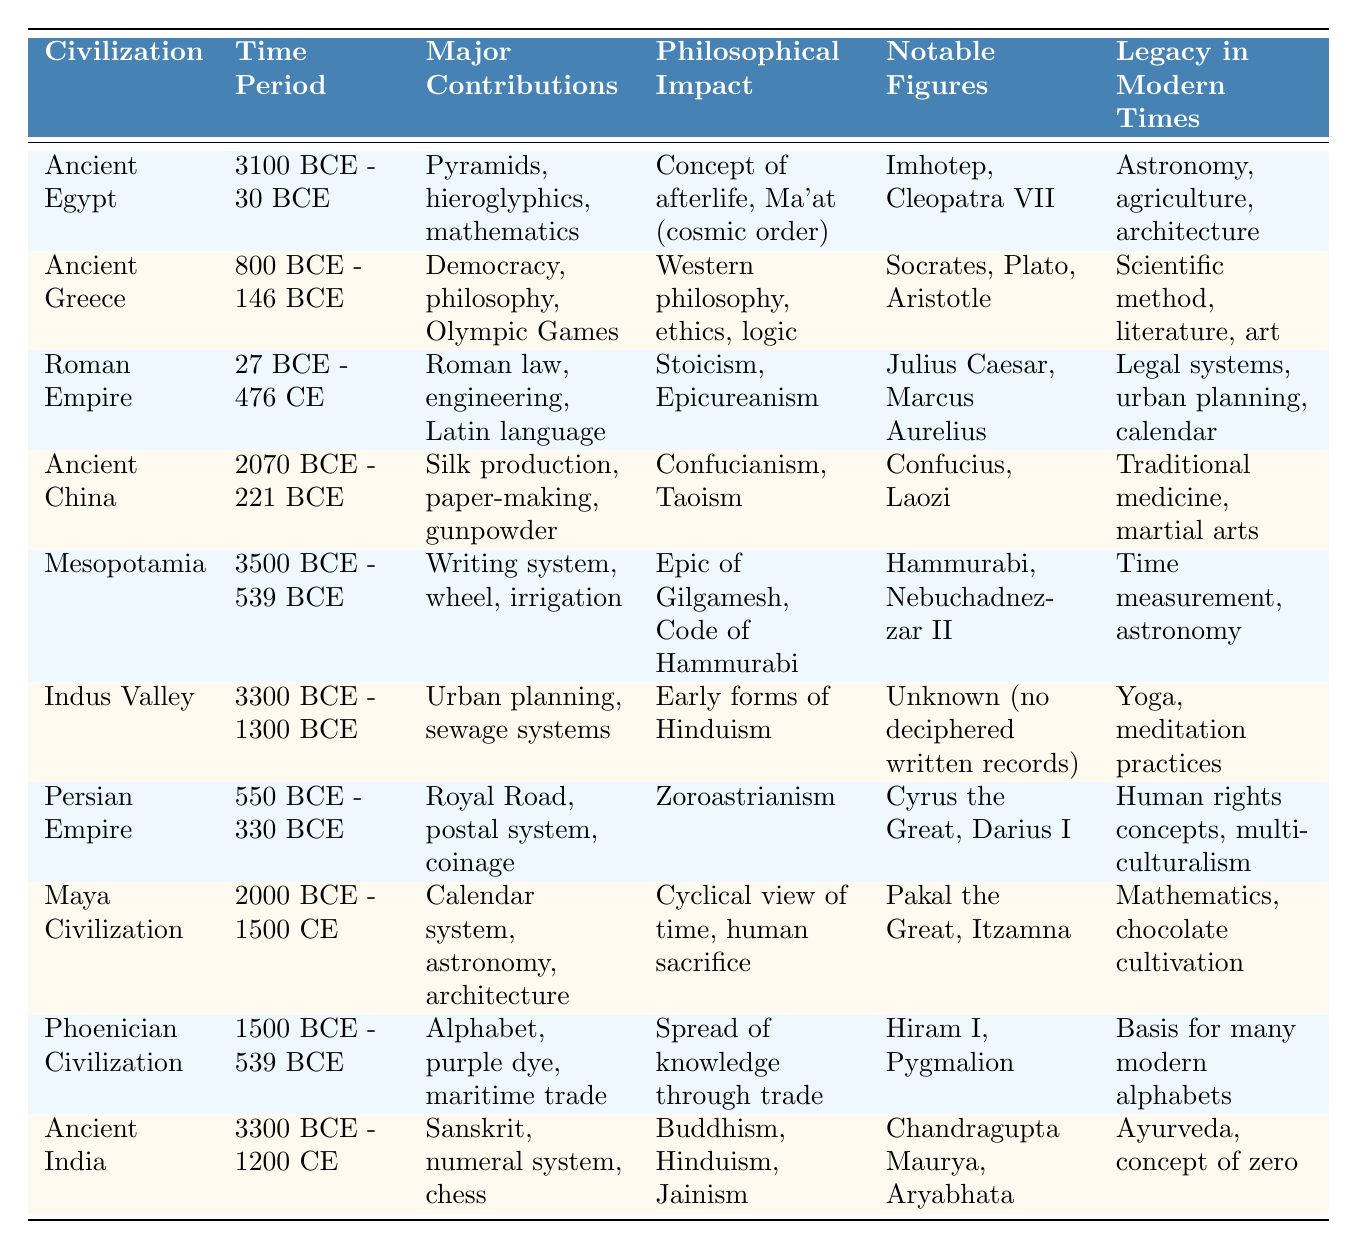What is the time period of Ancient Egypt? Referring to the table, Ancient Egypt has the time period listed as "3100 BCE - 30 BCE."
Answer: 3100 BCE - 30 BCE Which civilization is noted for the development of democracy? The table indicates that Ancient Greece is known for its major contributions, which include democracy.
Answer: Ancient Greece How many civilizations had their time periods ending before the Common Era (CE)? Analyzing the time periods listed, Ancient Egypt, Ancient Greece, Mesopotamia, Indus Valley, Persian Empire, and Phoenician Civilization all ended before the Common Era, totaling six civilizations.
Answer: 6 Which civilization contributed to the development of the Latin language? According to the table, the Roman Empire is responsible for contributing to the Latin language.
Answer: Roman Empire Is the concept of the afterlife associated with Ancient Egypt? Yes, the table specifically mentions that Ancient Egypt had a philosophical impact related to the concept of the afterlife.
Answer: Yes Which civilization's major contributions include urban planning and sewage systems? The table states that the Indus Valley civilization is known for its contributions in urban planning and sewage systems.
Answer: Indus Valley What philosophical impacts are associated with the Ancient China civilization? The table lists Confucianism and Taoism as the primary philosophical impacts associated with Ancient China.
Answer: Confucianism, Taoism Which civilization is recognized for its influential figures like Socrates, Plato, and Aristotle? The table identifies Ancient Greece as the civilization associated with notable figures including Socrates, Plato, and Aristotle.
Answer: Ancient Greece Which two ancient civilizations are known for their contributions to mathematics? Both Ancient Egypt and the Maya Civilization are mentioned in the table for their contributions to mathematics.
Answer: Ancient Egypt, Maya Civilization What notable figures are associated with the Persian Empire? The table shows that notable figures of the Persian Empire include Cyrus the Great and Darius I.
Answer: Cyrus the Great, Darius I Which civilization had early forms of Hinduism as a philosophical impact? The table indicates that the Indus Valley civilization is recognized for its early forms of Hinduism.
Answer: Indus Valley What is the legacy of the Roman Empire in modern times? The table indicates that the Roman Empire's legacy includes legal systems, urban planning, and the calendar in modern times.
Answer: Legal systems, urban planning, calendar Which civilization's contributions included silk production and gunpowder? The table clearly states that Ancient China is known for its contributions such as silk production and gunpowder.
Answer: Ancient China How many civilizations mentioned contributed to the development of writing systems? According to the table, Mesopotamia is identified for its writing system, while the Phoenician Civilization contributed to the alphabet. Hence, two civilizations contributed to writing systems.
Answer: 2 Does Ancient Greece have a lasting impact on the scientific method? Yes, the major contributions of Ancient Greece include the scientific method, as noted in the table.
Answer: Yes Which civilization had a significant philosophical impact related to Zoroastrianism? The table specifies that the Persian Empire had a philosophical impact related to Zoroastrianism.
Answer: Persian Empire 